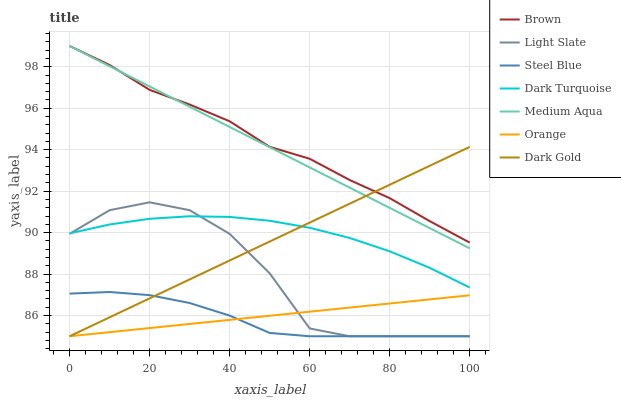Does Steel Blue have the minimum area under the curve?
Answer yes or no. Yes. Does Brown have the maximum area under the curve?
Answer yes or no. Yes. Does Dark Gold have the minimum area under the curve?
Answer yes or no. No. Does Dark Gold have the maximum area under the curve?
Answer yes or no. No. Is Medium Aqua the smoothest?
Answer yes or no. Yes. Is Light Slate the roughest?
Answer yes or no. Yes. Is Dark Gold the smoothest?
Answer yes or no. No. Is Dark Gold the roughest?
Answer yes or no. No. Does Dark Gold have the lowest value?
Answer yes or no. Yes. Does Dark Turquoise have the lowest value?
Answer yes or no. No. Does Medium Aqua have the highest value?
Answer yes or no. Yes. Does Dark Gold have the highest value?
Answer yes or no. No. Is Orange less than Dark Turquoise?
Answer yes or no. Yes. Is Medium Aqua greater than Light Slate?
Answer yes or no. Yes. Does Orange intersect Steel Blue?
Answer yes or no. Yes. Is Orange less than Steel Blue?
Answer yes or no. No. Is Orange greater than Steel Blue?
Answer yes or no. No. Does Orange intersect Dark Turquoise?
Answer yes or no. No. 